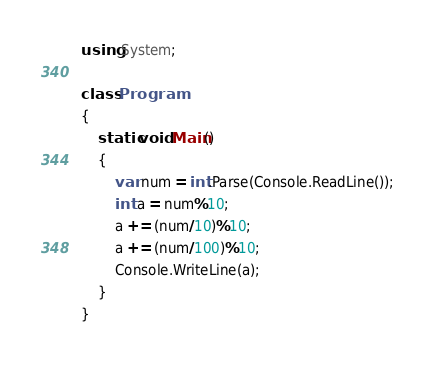<code> <loc_0><loc_0><loc_500><loc_500><_C#_>using System;

class Program
{
	static void Main()
    {
    	var num = int.Parse(Console.ReadLine());
      	int a = num%10;
      	a += (num/10)%10;
      	a += (num/100)%10;      
      	Console.WriteLine(a);
    }
}</code> 